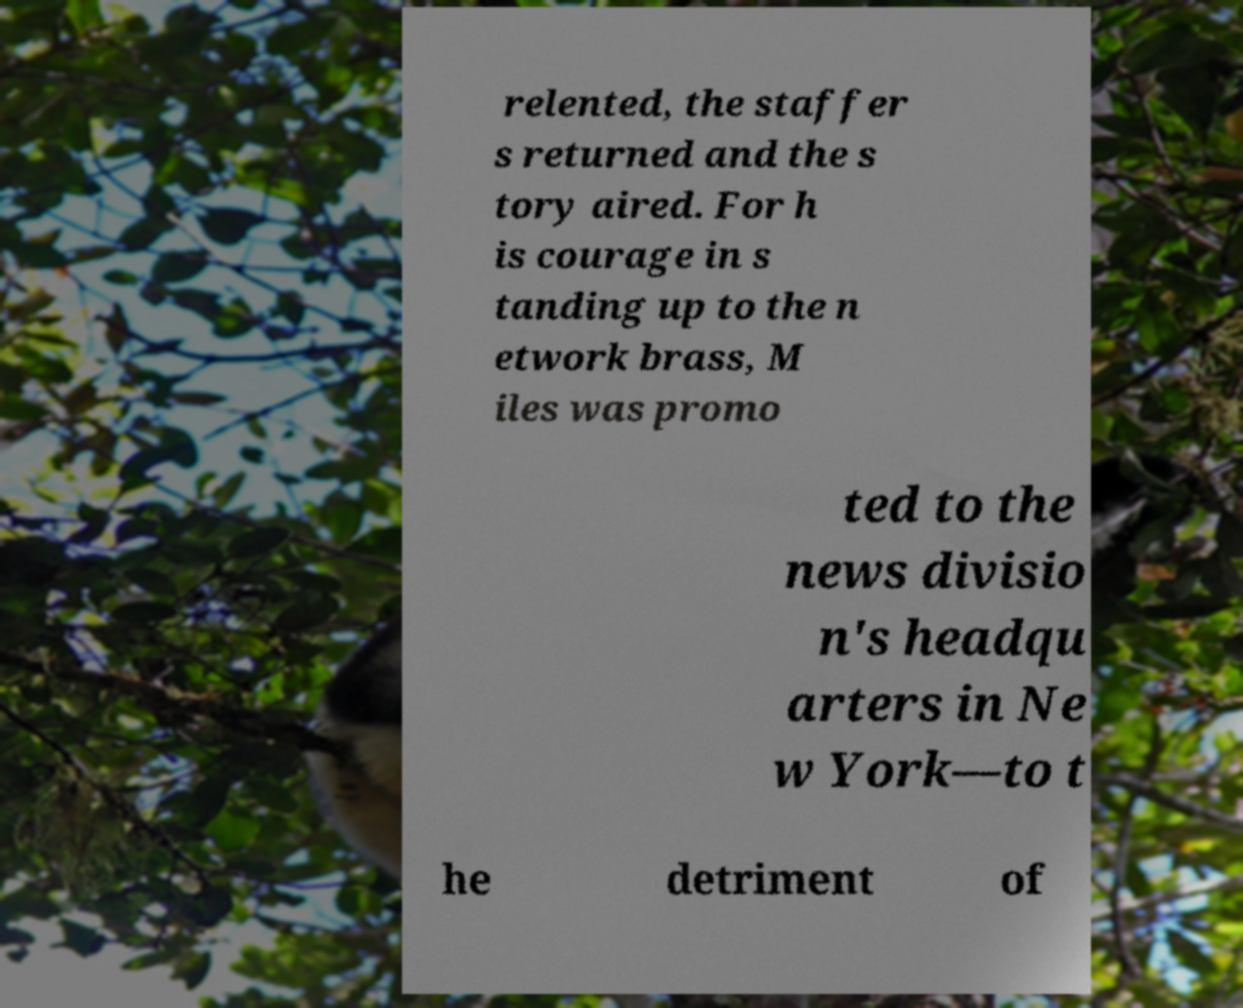Please read and relay the text visible in this image. What does it say? relented, the staffer s returned and the s tory aired. For h is courage in s tanding up to the n etwork brass, M iles was promo ted to the news divisio n's headqu arters in Ne w York—to t he detriment of 